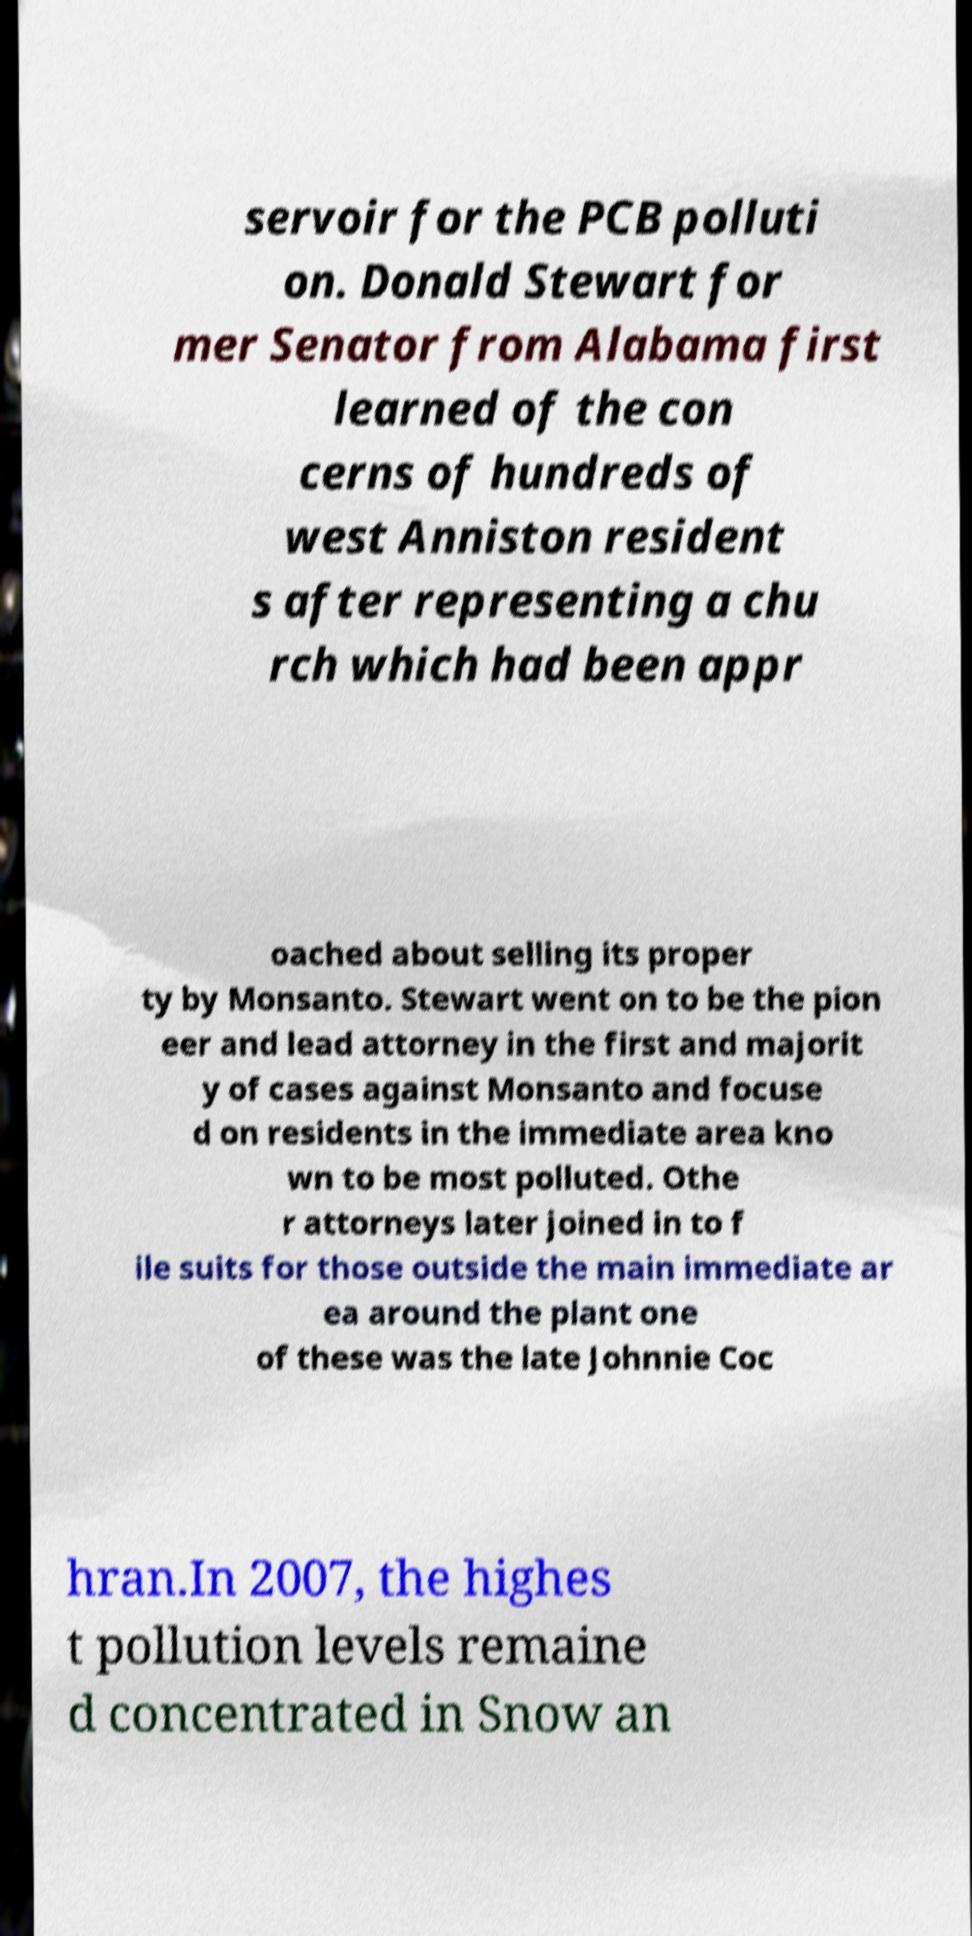Can you read and provide the text displayed in the image?This photo seems to have some interesting text. Can you extract and type it out for me? servoir for the PCB polluti on. Donald Stewart for mer Senator from Alabama first learned of the con cerns of hundreds of west Anniston resident s after representing a chu rch which had been appr oached about selling its proper ty by Monsanto. Stewart went on to be the pion eer and lead attorney in the first and majorit y of cases against Monsanto and focuse d on residents in the immediate area kno wn to be most polluted. Othe r attorneys later joined in to f ile suits for those outside the main immediate ar ea around the plant one of these was the late Johnnie Coc hran.In 2007, the highes t pollution levels remaine d concentrated in Snow an 